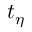Convert formula to latex. <formula><loc_0><loc_0><loc_500><loc_500>t _ { \eta }</formula> 